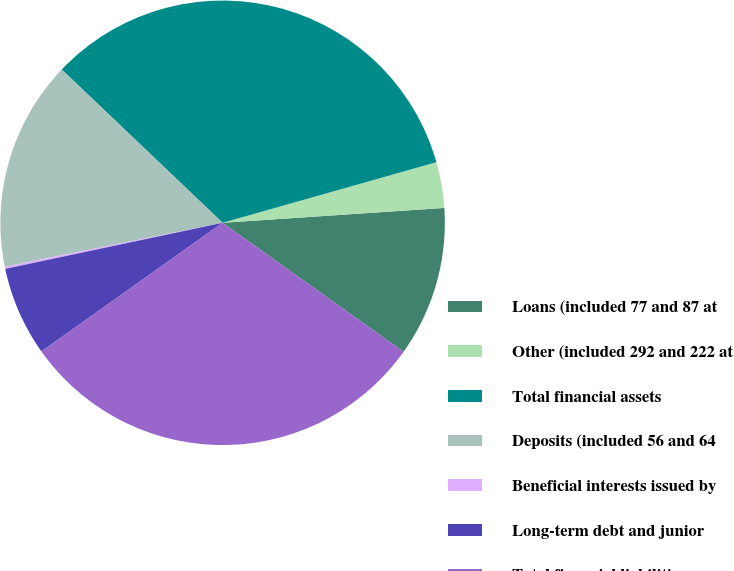Convert chart to OTSL. <chart><loc_0><loc_0><loc_500><loc_500><pie_chart><fcel>Loans (included 77 and 87 at<fcel>Other (included 292 and 222 at<fcel>Total financial assets<fcel>Deposits (included 56 and 64<fcel>Beneficial interests issued by<fcel>Long-term debt and junior<fcel>Total financial liabilities<nl><fcel>10.92%<fcel>3.33%<fcel>33.49%<fcel>15.28%<fcel>0.16%<fcel>6.5%<fcel>30.32%<nl></chart> 